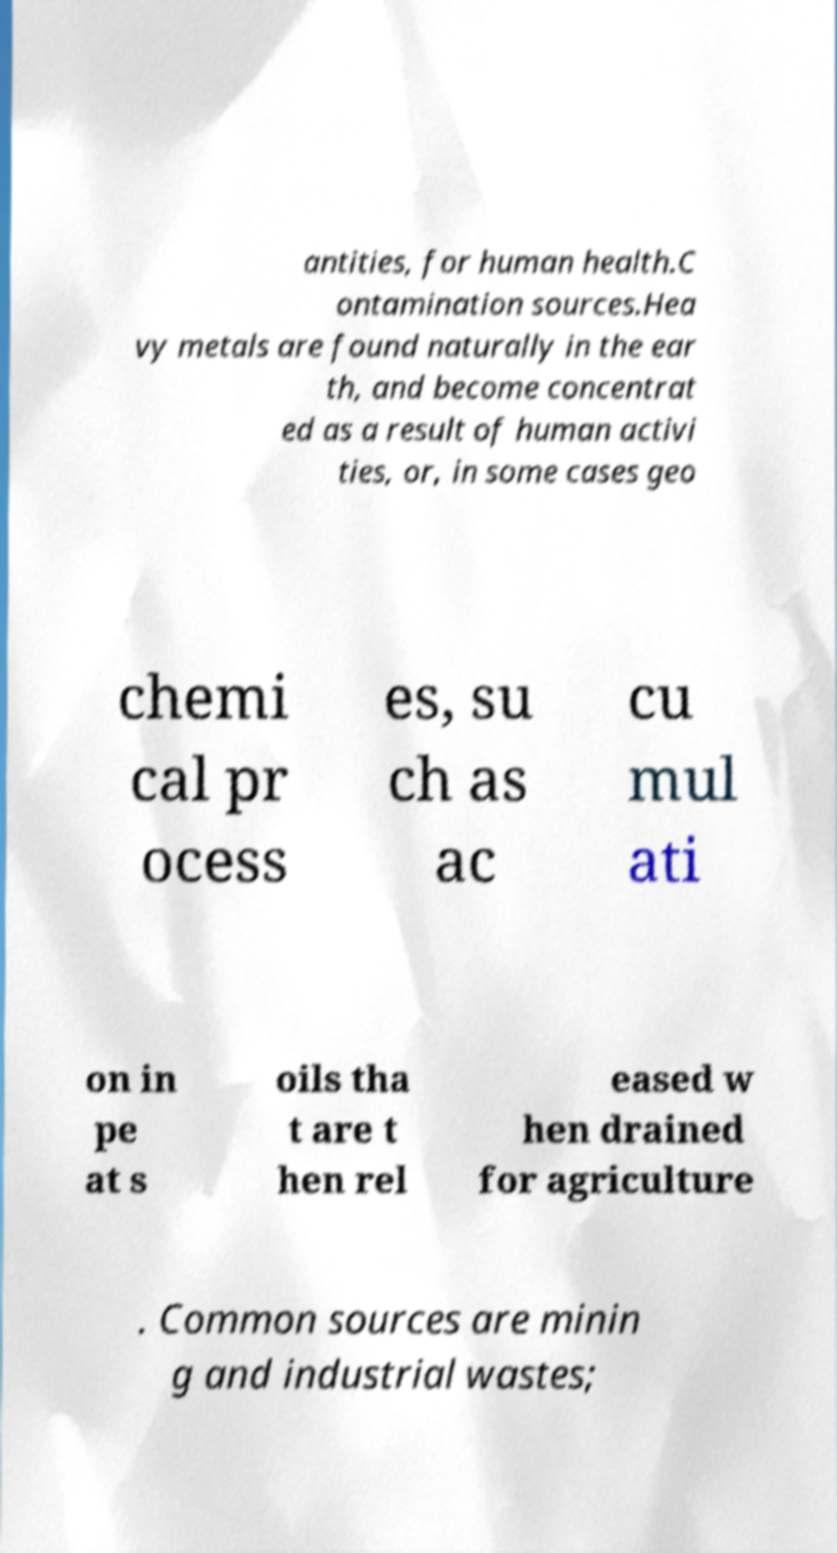Could you extract and type out the text from this image? antities, for human health.C ontamination sources.Hea vy metals are found naturally in the ear th, and become concentrat ed as a result of human activi ties, or, in some cases geo chemi cal pr ocess es, su ch as ac cu mul ati on in pe at s oils tha t are t hen rel eased w hen drained for agriculture . Common sources are minin g and industrial wastes; 